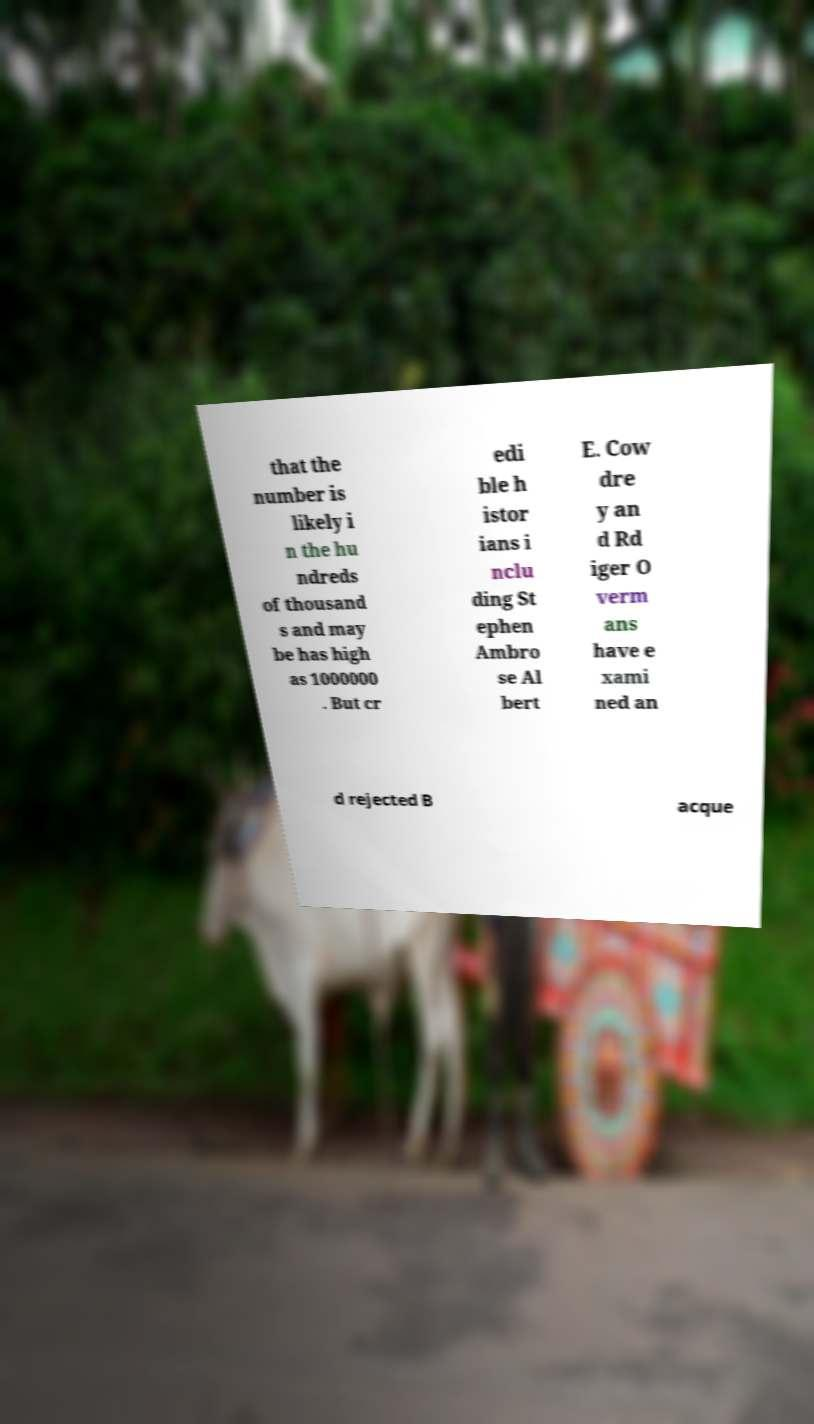For documentation purposes, I need the text within this image transcribed. Could you provide that? that the number is likely i n the hu ndreds of thousand s and may be has high as 1000000 . But cr edi ble h istor ians i nclu ding St ephen Ambro se Al bert E. Cow dre y an d Rd iger O verm ans have e xami ned an d rejected B acque 